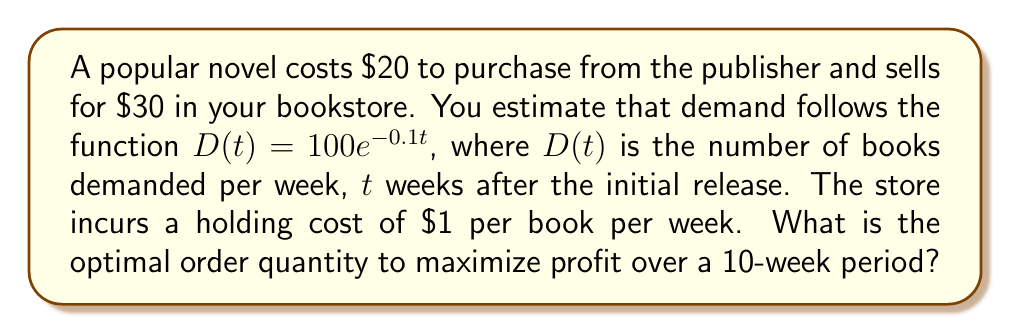Teach me how to tackle this problem. Let's approach this step-by-step:

1) First, we need to calculate the total demand over 10 weeks:

   $$\int_0^{10} 100e^{-0.1t} dt = -1000e^{-0.1t}\Big|_0^{10} = 1000 - 1000e^{-1} \approx 632.12$$

2) Let $Q$ be the order quantity. The total cost function will be:

   $$TC(Q) = 20Q + 1 \cdot \frac{Q}{2} \cdot 10$$

   Where $20Q$ is the purchase cost and $\frac{Q}{2} \cdot 10$ is the average inventory over 10 weeks.

3) The total revenue function is:

   $$TR(Q) = 30 \cdot \min(Q, 632.12)$$

4) The profit function is:

   $$P(Q) = TR(Q) - TC(Q) = 30 \cdot \min(Q, 632.12) - (20Q + 5Q)$$

5) For $Q \leq 632.12$, we have:

   $$P(Q) = 30Q - 25Q = 5Q$$

   This is increasing in $Q$, so the optimal $Q$ must be at least 632.12.

6) For $Q > 632.12$, we have:

   $$P(Q) = 30 \cdot 632.12 - 25Q$$

   This is decreasing in $Q$, so the optimal $Q$ must be no more than 632.12.

7) Therefore, the optimal order quantity is exactly 632.12 books.
Answer: 632 books 